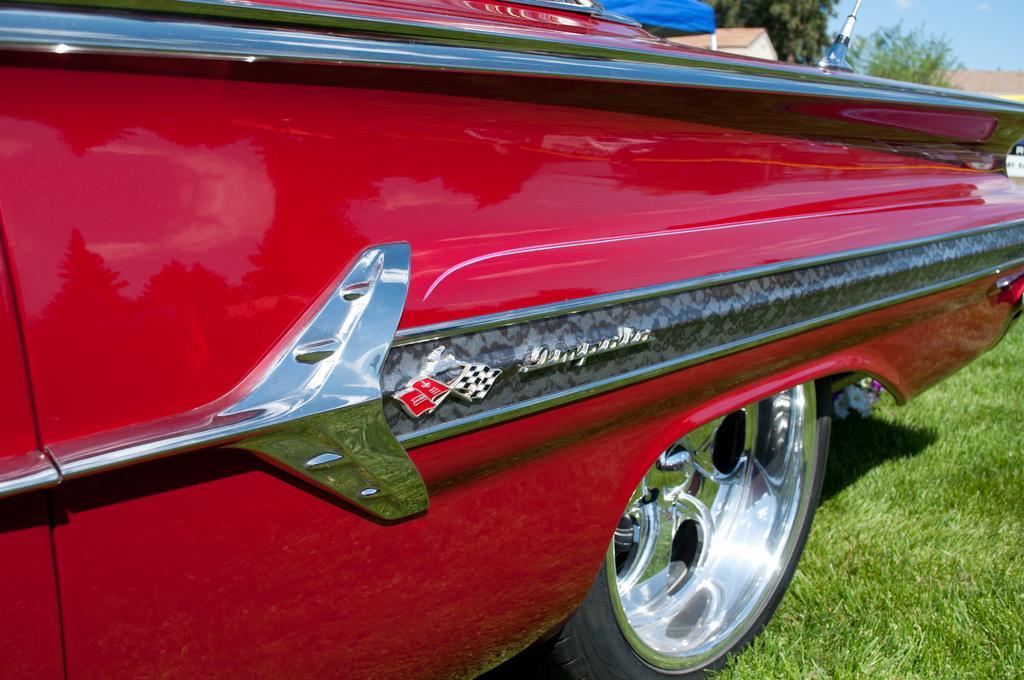Can you describe this image briefly? In the image there is a red color car with wheel. To the right bottom corner of the image there is ground on the grass. To the right top corner of the image there are trees, house roofs and also there is a sky. 